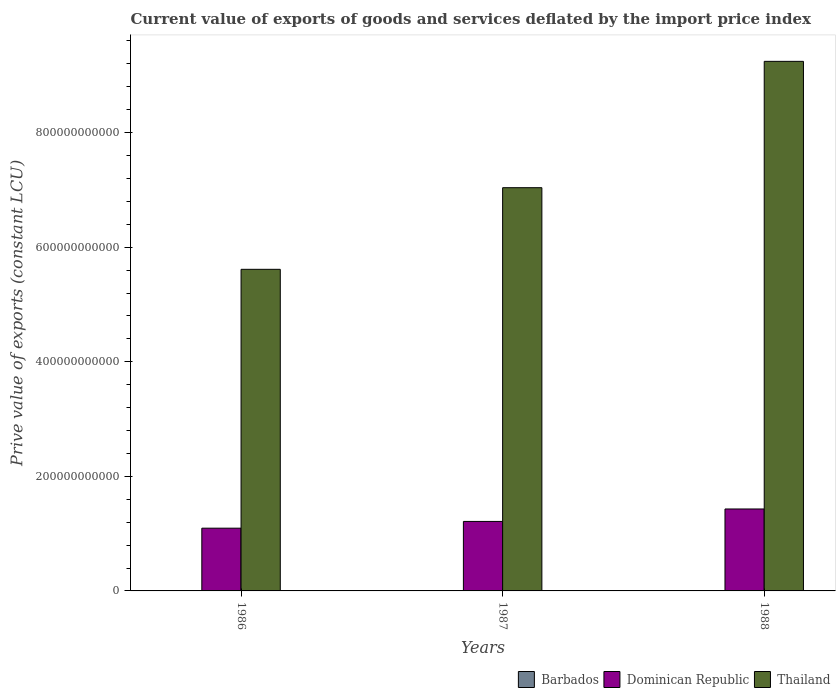How many different coloured bars are there?
Provide a short and direct response. 3. How many groups of bars are there?
Keep it short and to the point. 3. How many bars are there on the 1st tick from the left?
Provide a succinct answer. 3. How many bars are there on the 1st tick from the right?
Offer a very short reply. 3. What is the label of the 3rd group of bars from the left?
Give a very brief answer. 1988. What is the prive value of exports in Barbados in 1986?
Make the answer very short. 4.36e+08. Across all years, what is the maximum prive value of exports in Thailand?
Your answer should be very brief. 9.24e+11. Across all years, what is the minimum prive value of exports in Thailand?
Provide a succinct answer. 5.61e+11. What is the total prive value of exports in Barbados in the graph?
Your answer should be compact. 1.17e+09. What is the difference between the prive value of exports in Barbados in 1986 and that in 1987?
Provide a short and direct response. 7.67e+07. What is the difference between the prive value of exports in Barbados in 1988 and the prive value of exports in Thailand in 1987?
Keep it short and to the point. -7.03e+11. What is the average prive value of exports in Barbados per year?
Offer a terse response. 3.91e+08. In the year 1987, what is the difference between the prive value of exports in Dominican Republic and prive value of exports in Thailand?
Provide a short and direct response. -5.83e+11. In how many years, is the prive value of exports in Dominican Republic greater than 80000000000 LCU?
Provide a succinct answer. 3. What is the ratio of the prive value of exports in Barbados in 1986 to that in 1987?
Provide a succinct answer. 1.21. Is the prive value of exports in Barbados in 1986 less than that in 1987?
Offer a terse response. No. What is the difference between the highest and the second highest prive value of exports in Barbados?
Provide a short and direct response. 5.72e+07. What is the difference between the highest and the lowest prive value of exports in Barbados?
Your answer should be very brief. 7.67e+07. In how many years, is the prive value of exports in Dominican Republic greater than the average prive value of exports in Dominican Republic taken over all years?
Your answer should be very brief. 1. What does the 2nd bar from the left in 1986 represents?
Offer a terse response. Dominican Republic. What does the 1st bar from the right in 1986 represents?
Make the answer very short. Thailand. How many bars are there?
Provide a succinct answer. 9. Are all the bars in the graph horizontal?
Give a very brief answer. No. How many years are there in the graph?
Provide a short and direct response. 3. What is the difference between two consecutive major ticks on the Y-axis?
Provide a short and direct response. 2.00e+11. Are the values on the major ticks of Y-axis written in scientific E-notation?
Your answer should be compact. No. Does the graph contain grids?
Your answer should be very brief. No. Where does the legend appear in the graph?
Offer a terse response. Bottom right. How are the legend labels stacked?
Offer a terse response. Horizontal. What is the title of the graph?
Keep it short and to the point. Current value of exports of goods and services deflated by the import price index. What is the label or title of the Y-axis?
Give a very brief answer. Prive value of exports (constant LCU). What is the Prive value of exports (constant LCU) of Barbados in 1986?
Make the answer very short. 4.36e+08. What is the Prive value of exports (constant LCU) of Dominican Republic in 1986?
Give a very brief answer. 1.10e+11. What is the Prive value of exports (constant LCU) of Thailand in 1986?
Keep it short and to the point. 5.61e+11. What is the Prive value of exports (constant LCU) of Barbados in 1987?
Keep it short and to the point. 3.59e+08. What is the Prive value of exports (constant LCU) of Dominican Republic in 1987?
Your answer should be very brief. 1.21e+11. What is the Prive value of exports (constant LCU) of Thailand in 1987?
Your answer should be compact. 7.04e+11. What is the Prive value of exports (constant LCU) in Barbados in 1988?
Provide a succinct answer. 3.79e+08. What is the Prive value of exports (constant LCU) in Dominican Republic in 1988?
Provide a short and direct response. 1.43e+11. What is the Prive value of exports (constant LCU) in Thailand in 1988?
Offer a terse response. 9.24e+11. Across all years, what is the maximum Prive value of exports (constant LCU) of Barbados?
Offer a very short reply. 4.36e+08. Across all years, what is the maximum Prive value of exports (constant LCU) of Dominican Republic?
Ensure brevity in your answer.  1.43e+11. Across all years, what is the maximum Prive value of exports (constant LCU) in Thailand?
Ensure brevity in your answer.  9.24e+11. Across all years, what is the minimum Prive value of exports (constant LCU) in Barbados?
Your response must be concise. 3.59e+08. Across all years, what is the minimum Prive value of exports (constant LCU) of Dominican Republic?
Offer a terse response. 1.10e+11. Across all years, what is the minimum Prive value of exports (constant LCU) in Thailand?
Your response must be concise. 5.61e+11. What is the total Prive value of exports (constant LCU) in Barbados in the graph?
Offer a terse response. 1.17e+09. What is the total Prive value of exports (constant LCU) of Dominican Republic in the graph?
Keep it short and to the point. 3.74e+11. What is the total Prive value of exports (constant LCU) in Thailand in the graph?
Provide a short and direct response. 2.19e+12. What is the difference between the Prive value of exports (constant LCU) in Barbados in 1986 and that in 1987?
Provide a short and direct response. 7.67e+07. What is the difference between the Prive value of exports (constant LCU) in Dominican Republic in 1986 and that in 1987?
Ensure brevity in your answer.  -1.18e+1. What is the difference between the Prive value of exports (constant LCU) of Thailand in 1986 and that in 1987?
Keep it short and to the point. -1.42e+11. What is the difference between the Prive value of exports (constant LCU) of Barbados in 1986 and that in 1988?
Give a very brief answer. 5.72e+07. What is the difference between the Prive value of exports (constant LCU) of Dominican Republic in 1986 and that in 1988?
Provide a succinct answer. -3.35e+1. What is the difference between the Prive value of exports (constant LCU) in Thailand in 1986 and that in 1988?
Make the answer very short. -3.63e+11. What is the difference between the Prive value of exports (constant LCU) of Barbados in 1987 and that in 1988?
Make the answer very short. -1.95e+07. What is the difference between the Prive value of exports (constant LCU) of Dominican Republic in 1987 and that in 1988?
Provide a succinct answer. -2.17e+1. What is the difference between the Prive value of exports (constant LCU) in Thailand in 1987 and that in 1988?
Provide a succinct answer. -2.21e+11. What is the difference between the Prive value of exports (constant LCU) of Barbados in 1986 and the Prive value of exports (constant LCU) of Dominican Republic in 1987?
Your answer should be compact. -1.21e+11. What is the difference between the Prive value of exports (constant LCU) in Barbados in 1986 and the Prive value of exports (constant LCU) in Thailand in 1987?
Your answer should be very brief. -7.03e+11. What is the difference between the Prive value of exports (constant LCU) of Dominican Republic in 1986 and the Prive value of exports (constant LCU) of Thailand in 1987?
Give a very brief answer. -5.94e+11. What is the difference between the Prive value of exports (constant LCU) in Barbados in 1986 and the Prive value of exports (constant LCU) in Dominican Republic in 1988?
Offer a very short reply. -1.43e+11. What is the difference between the Prive value of exports (constant LCU) in Barbados in 1986 and the Prive value of exports (constant LCU) in Thailand in 1988?
Provide a succinct answer. -9.24e+11. What is the difference between the Prive value of exports (constant LCU) of Dominican Republic in 1986 and the Prive value of exports (constant LCU) of Thailand in 1988?
Provide a short and direct response. -8.15e+11. What is the difference between the Prive value of exports (constant LCU) of Barbados in 1987 and the Prive value of exports (constant LCU) of Dominican Republic in 1988?
Keep it short and to the point. -1.43e+11. What is the difference between the Prive value of exports (constant LCU) in Barbados in 1987 and the Prive value of exports (constant LCU) in Thailand in 1988?
Offer a very short reply. -9.24e+11. What is the difference between the Prive value of exports (constant LCU) of Dominican Republic in 1987 and the Prive value of exports (constant LCU) of Thailand in 1988?
Offer a terse response. -8.03e+11. What is the average Prive value of exports (constant LCU) of Barbados per year?
Provide a short and direct response. 3.91e+08. What is the average Prive value of exports (constant LCU) of Dominican Republic per year?
Keep it short and to the point. 1.25e+11. What is the average Prive value of exports (constant LCU) in Thailand per year?
Provide a succinct answer. 7.30e+11. In the year 1986, what is the difference between the Prive value of exports (constant LCU) of Barbados and Prive value of exports (constant LCU) of Dominican Republic?
Keep it short and to the point. -1.09e+11. In the year 1986, what is the difference between the Prive value of exports (constant LCU) in Barbados and Prive value of exports (constant LCU) in Thailand?
Offer a terse response. -5.61e+11. In the year 1986, what is the difference between the Prive value of exports (constant LCU) in Dominican Republic and Prive value of exports (constant LCU) in Thailand?
Your answer should be very brief. -4.52e+11. In the year 1987, what is the difference between the Prive value of exports (constant LCU) of Barbados and Prive value of exports (constant LCU) of Dominican Republic?
Provide a short and direct response. -1.21e+11. In the year 1987, what is the difference between the Prive value of exports (constant LCU) of Barbados and Prive value of exports (constant LCU) of Thailand?
Offer a very short reply. -7.03e+11. In the year 1987, what is the difference between the Prive value of exports (constant LCU) in Dominican Republic and Prive value of exports (constant LCU) in Thailand?
Make the answer very short. -5.83e+11. In the year 1988, what is the difference between the Prive value of exports (constant LCU) in Barbados and Prive value of exports (constant LCU) in Dominican Republic?
Your response must be concise. -1.43e+11. In the year 1988, what is the difference between the Prive value of exports (constant LCU) in Barbados and Prive value of exports (constant LCU) in Thailand?
Give a very brief answer. -9.24e+11. In the year 1988, what is the difference between the Prive value of exports (constant LCU) of Dominican Republic and Prive value of exports (constant LCU) of Thailand?
Ensure brevity in your answer.  -7.81e+11. What is the ratio of the Prive value of exports (constant LCU) in Barbados in 1986 to that in 1987?
Make the answer very short. 1.21. What is the ratio of the Prive value of exports (constant LCU) of Dominican Republic in 1986 to that in 1987?
Your answer should be compact. 0.9. What is the ratio of the Prive value of exports (constant LCU) of Thailand in 1986 to that in 1987?
Your response must be concise. 0.8. What is the ratio of the Prive value of exports (constant LCU) of Barbados in 1986 to that in 1988?
Ensure brevity in your answer.  1.15. What is the ratio of the Prive value of exports (constant LCU) of Dominican Republic in 1986 to that in 1988?
Provide a short and direct response. 0.77. What is the ratio of the Prive value of exports (constant LCU) in Thailand in 1986 to that in 1988?
Make the answer very short. 0.61. What is the ratio of the Prive value of exports (constant LCU) in Barbados in 1987 to that in 1988?
Keep it short and to the point. 0.95. What is the ratio of the Prive value of exports (constant LCU) of Dominican Republic in 1987 to that in 1988?
Offer a very short reply. 0.85. What is the ratio of the Prive value of exports (constant LCU) of Thailand in 1987 to that in 1988?
Provide a short and direct response. 0.76. What is the difference between the highest and the second highest Prive value of exports (constant LCU) in Barbados?
Provide a succinct answer. 5.72e+07. What is the difference between the highest and the second highest Prive value of exports (constant LCU) in Dominican Republic?
Ensure brevity in your answer.  2.17e+1. What is the difference between the highest and the second highest Prive value of exports (constant LCU) in Thailand?
Keep it short and to the point. 2.21e+11. What is the difference between the highest and the lowest Prive value of exports (constant LCU) of Barbados?
Ensure brevity in your answer.  7.67e+07. What is the difference between the highest and the lowest Prive value of exports (constant LCU) of Dominican Republic?
Make the answer very short. 3.35e+1. What is the difference between the highest and the lowest Prive value of exports (constant LCU) in Thailand?
Keep it short and to the point. 3.63e+11. 